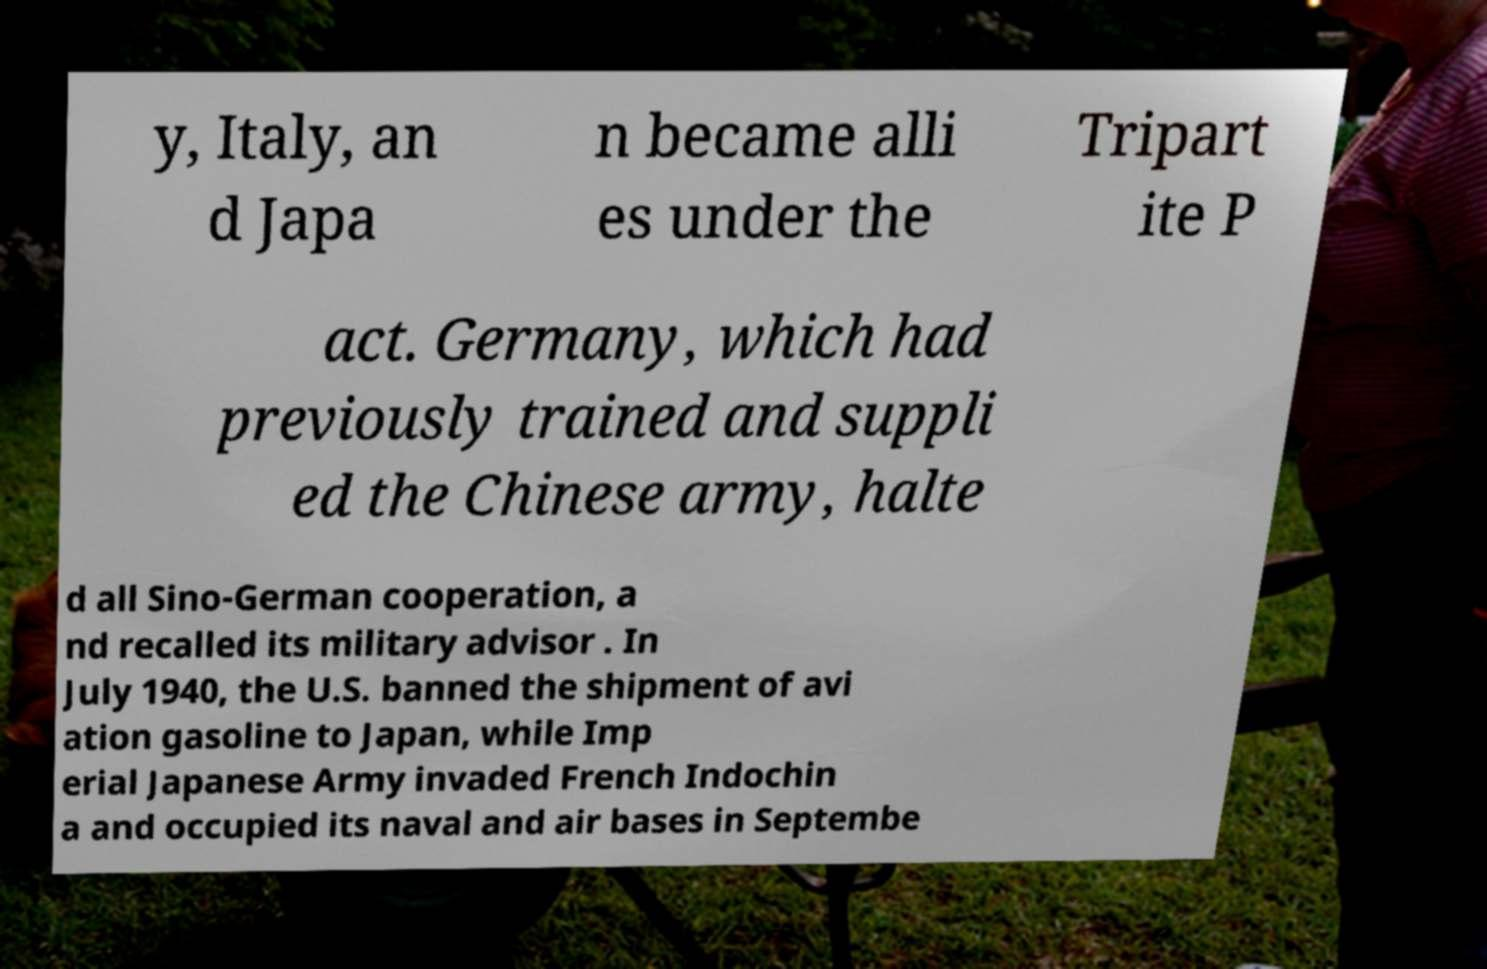Can you read and provide the text displayed in the image?This photo seems to have some interesting text. Can you extract and type it out for me? y, Italy, an d Japa n became alli es under the Tripart ite P act. Germany, which had previously trained and suppli ed the Chinese army, halte d all Sino-German cooperation, a nd recalled its military advisor . In July 1940, the U.S. banned the shipment of avi ation gasoline to Japan, while Imp erial Japanese Army invaded French Indochin a and occupied its naval and air bases in Septembe 